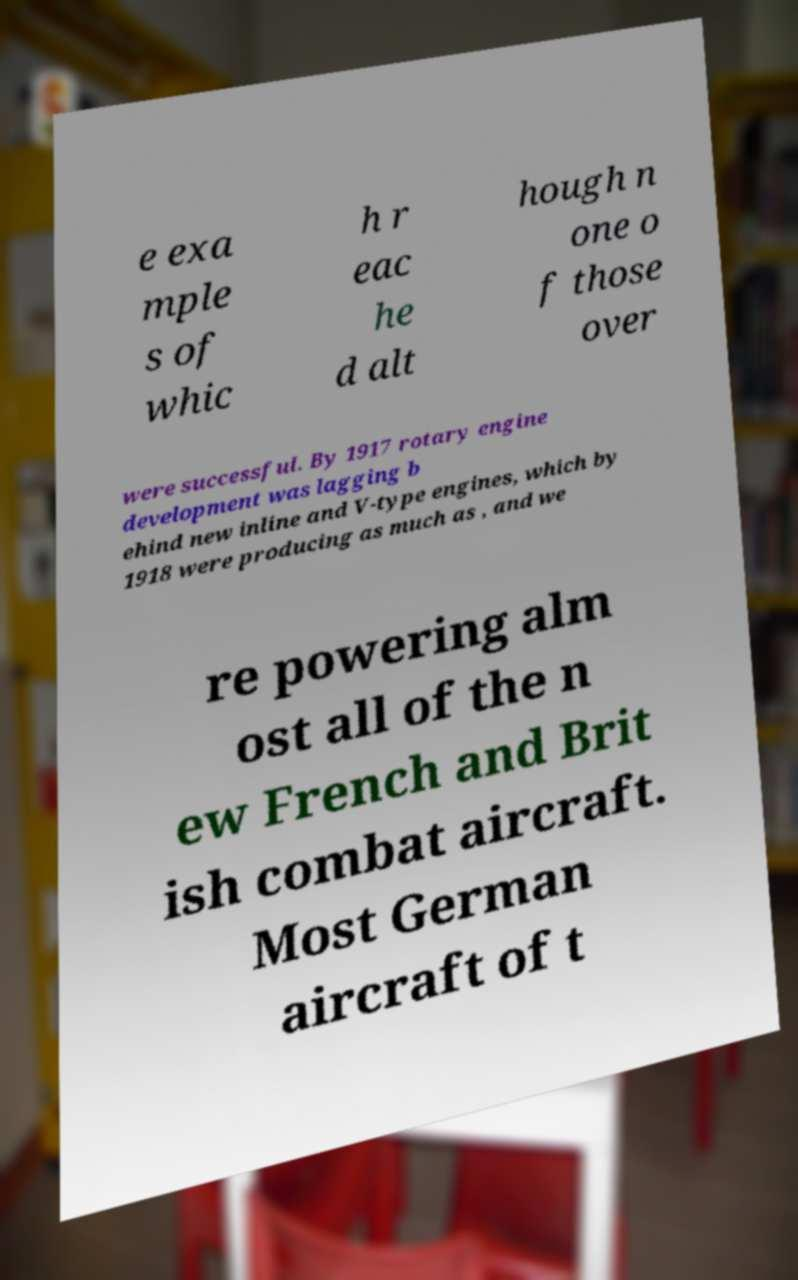Can you accurately transcribe the text from the provided image for me? e exa mple s of whic h r eac he d alt hough n one o f those over were successful. By 1917 rotary engine development was lagging b ehind new inline and V-type engines, which by 1918 were producing as much as , and we re powering alm ost all of the n ew French and Brit ish combat aircraft. Most German aircraft of t 